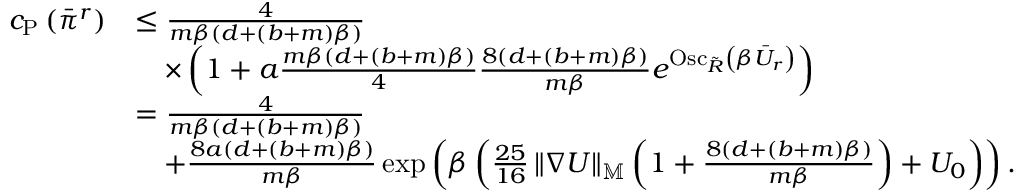<formula> <loc_0><loc_0><loc_500><loc_500>\begin{array} { r l } { c _ { P } \left ( \ B a r { \pi } ^ { r } \right ) } & { \leq \frac { 4 } { m \beta \left ( d + \left ( b + m \right ) \beta \right ) } } \\ & { \quad \times \left ( 1 + a \frac { m \beta \left ( d + \left ( b + m \right ) \beta \right ) } { 4 } \frac { 8 \left ( d + \left ( b + m \right ) \beta \right ) } { m \beta } e ^ { O s c _ { \tilde { R } } \left ( \beta \ B a r { U } _ { r } \right ) } \right ) } \\ & { = \frac { 4 } { m \beta \left ( d + \left ( b + m \right ) \beta \right ) } } \\ & { \quad + \frac { 8 a \left ( d + \left ( b + m \right ) \beta \right ) } { m \beta } \exp \left ( \beta \left ( \frac { 2 5 } { 1 6 } \left \| \nabla U \right \| _ { \mathbb { M } } \left ( 1 + \frac { 8 \left ( d + \left ( b + m \right ) \beta \right ) } { m \beta } \right ) + U _ { 0 } \right ) \right ) . } \end{array}</formula> 